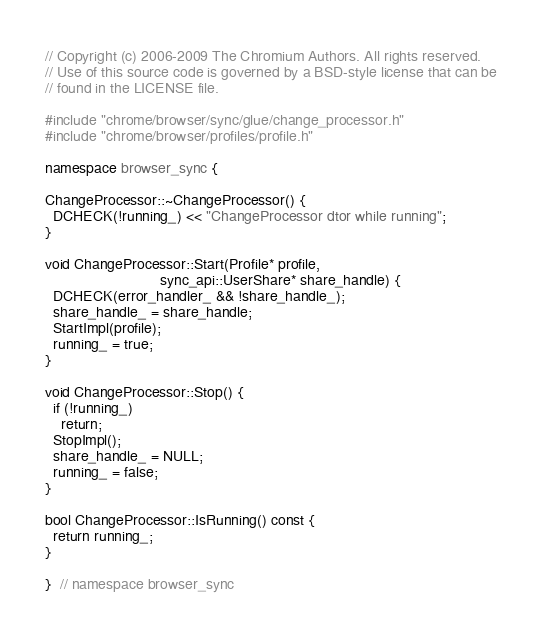Convert code to text. <code><loc_0><loc_0><loc_500><loc_500><_C++_>// Copyright (c) 2006-2009 The Chromium Authors. All rights reserved.
// Use of this source code is governed by a BSD-style license that can be
// found in the LICENSE file.

#include "chrome/browser/sync/glue/change_processor.h"
#include "chrome/browser/profiles/profile.h"

namespace browser_sync {

ChangeProcessor::~ChangeProcessor() {
  DCHECK(!running_) << "ChangeProcessor dtor while running";
}

void ChangeProcessor::Start(Profile* profile,
                            sync_api::UserShare* share_handle) {
  DCHECK(error_handler_ && !share_handle_);
  share_handle_ = share_handle;
  StartImpl(profile);
  running_ = true;
}

void ChangeProcessor::Stop() {
  if (!running_)
    return;
  StopImpl();
  share_handle_ = NULL;
  running_ = false;
}

bool ChangeProcessor::IsRunning() const {
  return running_;
}

}  // namespace browser_sync
</code> 